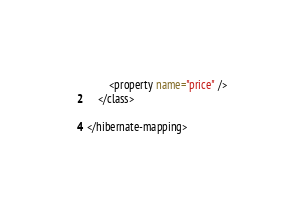<code> <loc_0><loc_0><loc_500><loc_500><_XML_>        <property name="price" />
    </class>

</hibernate-mapping>
</code> 